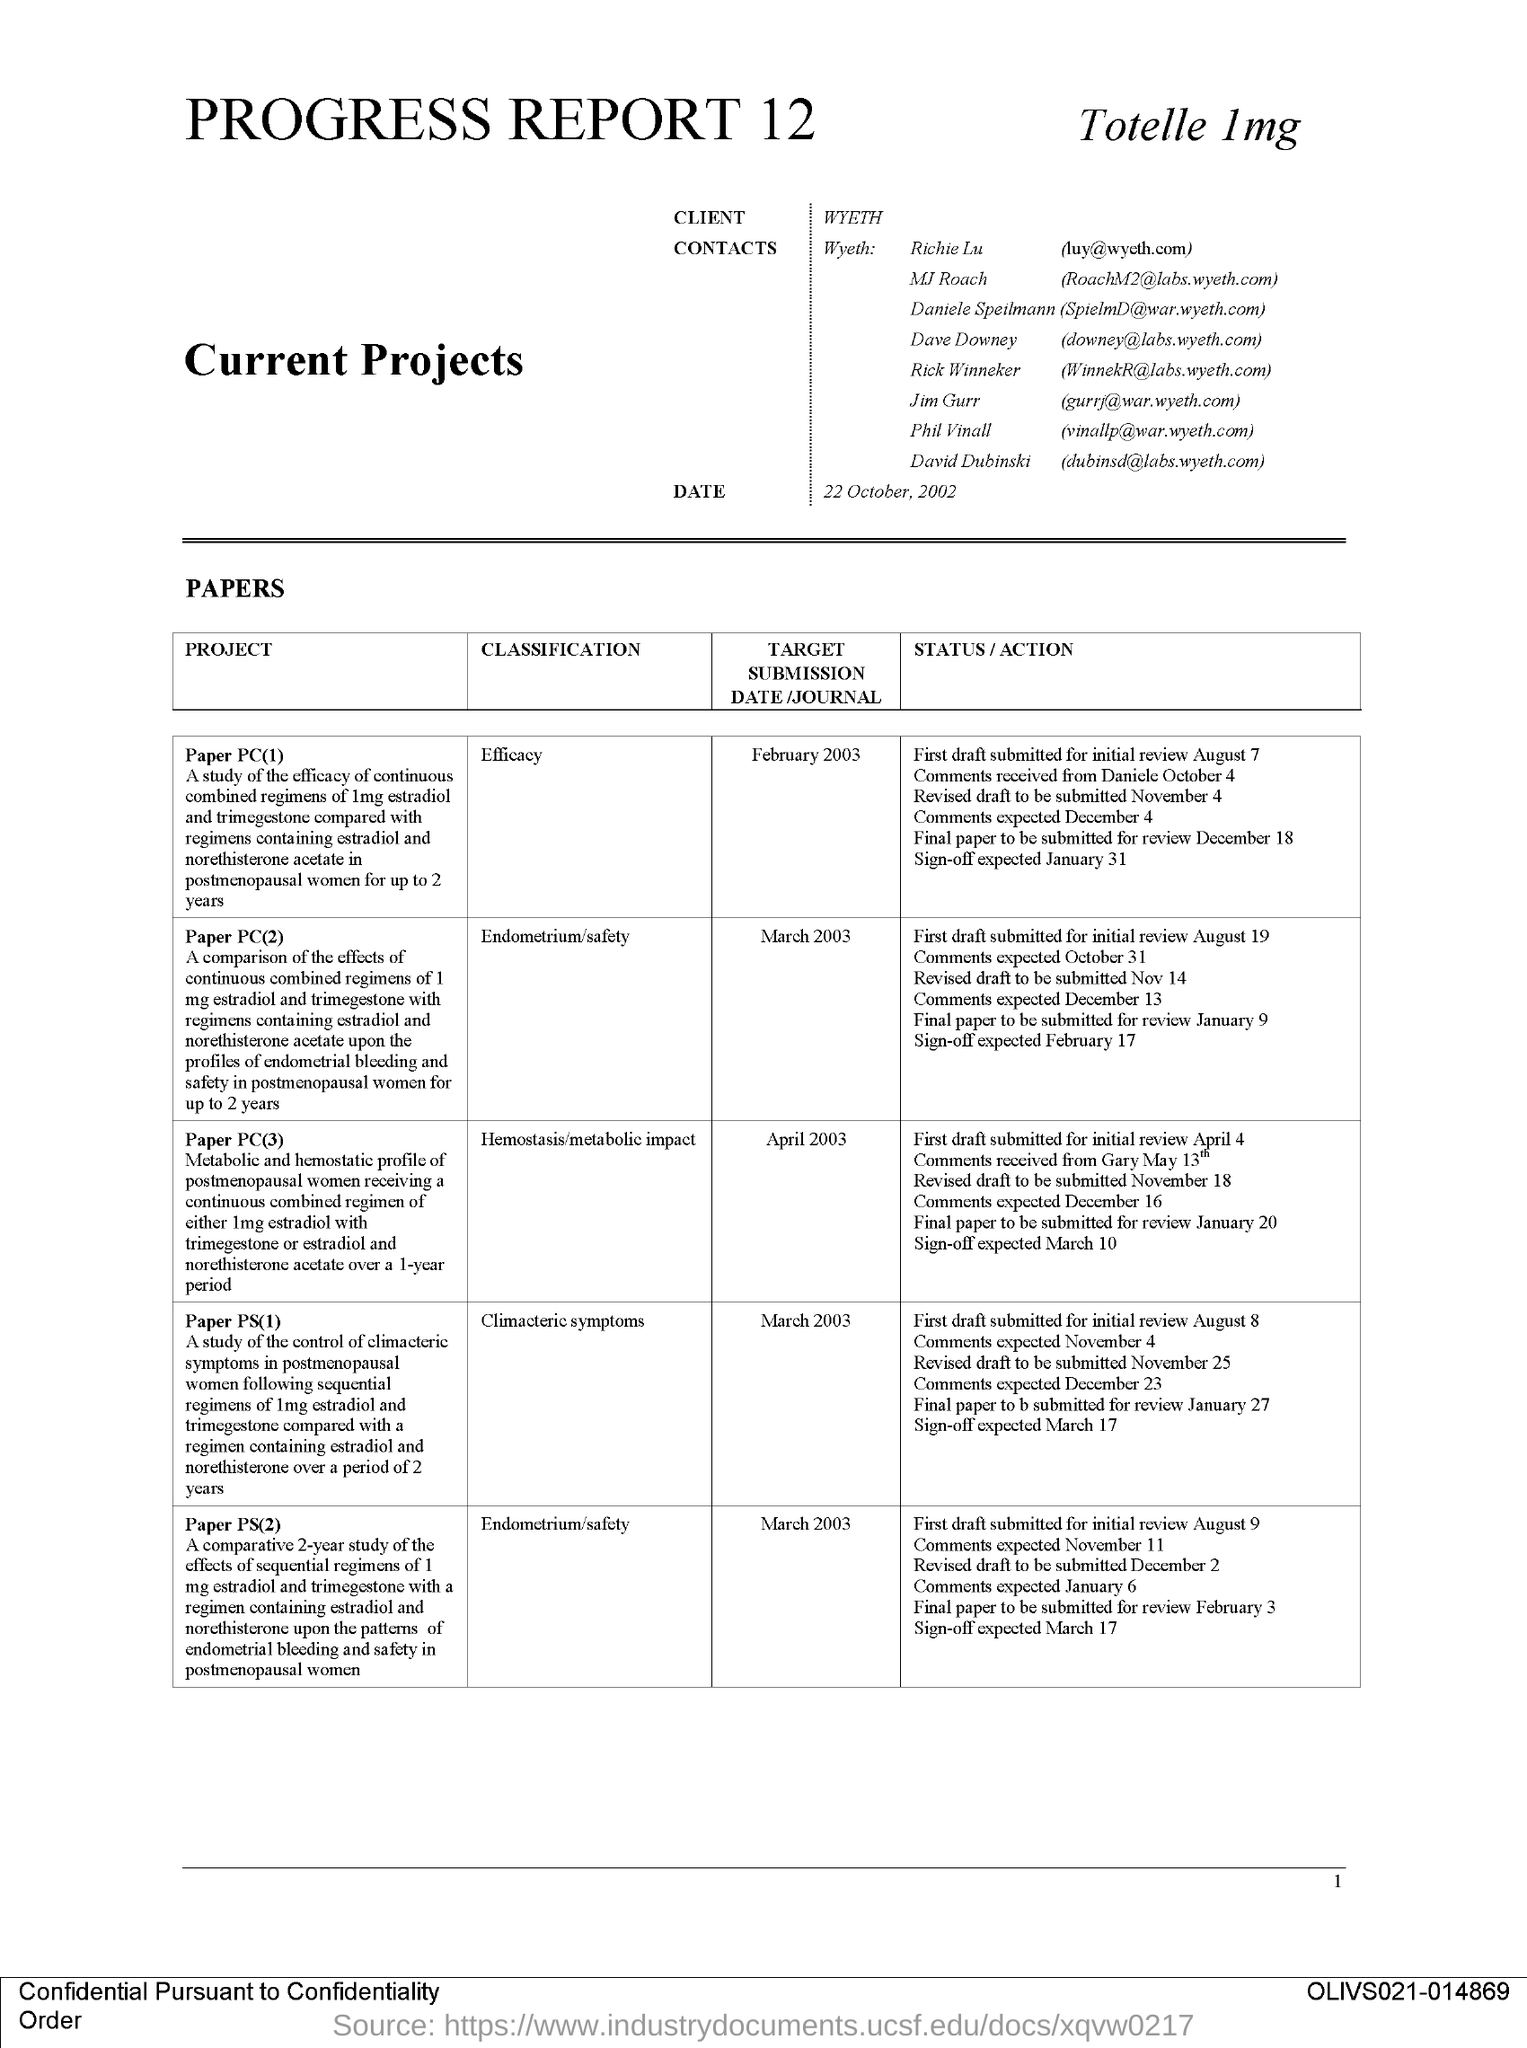Draw attention to some important aspects in this diagram. The client named in this document is WYETH. 